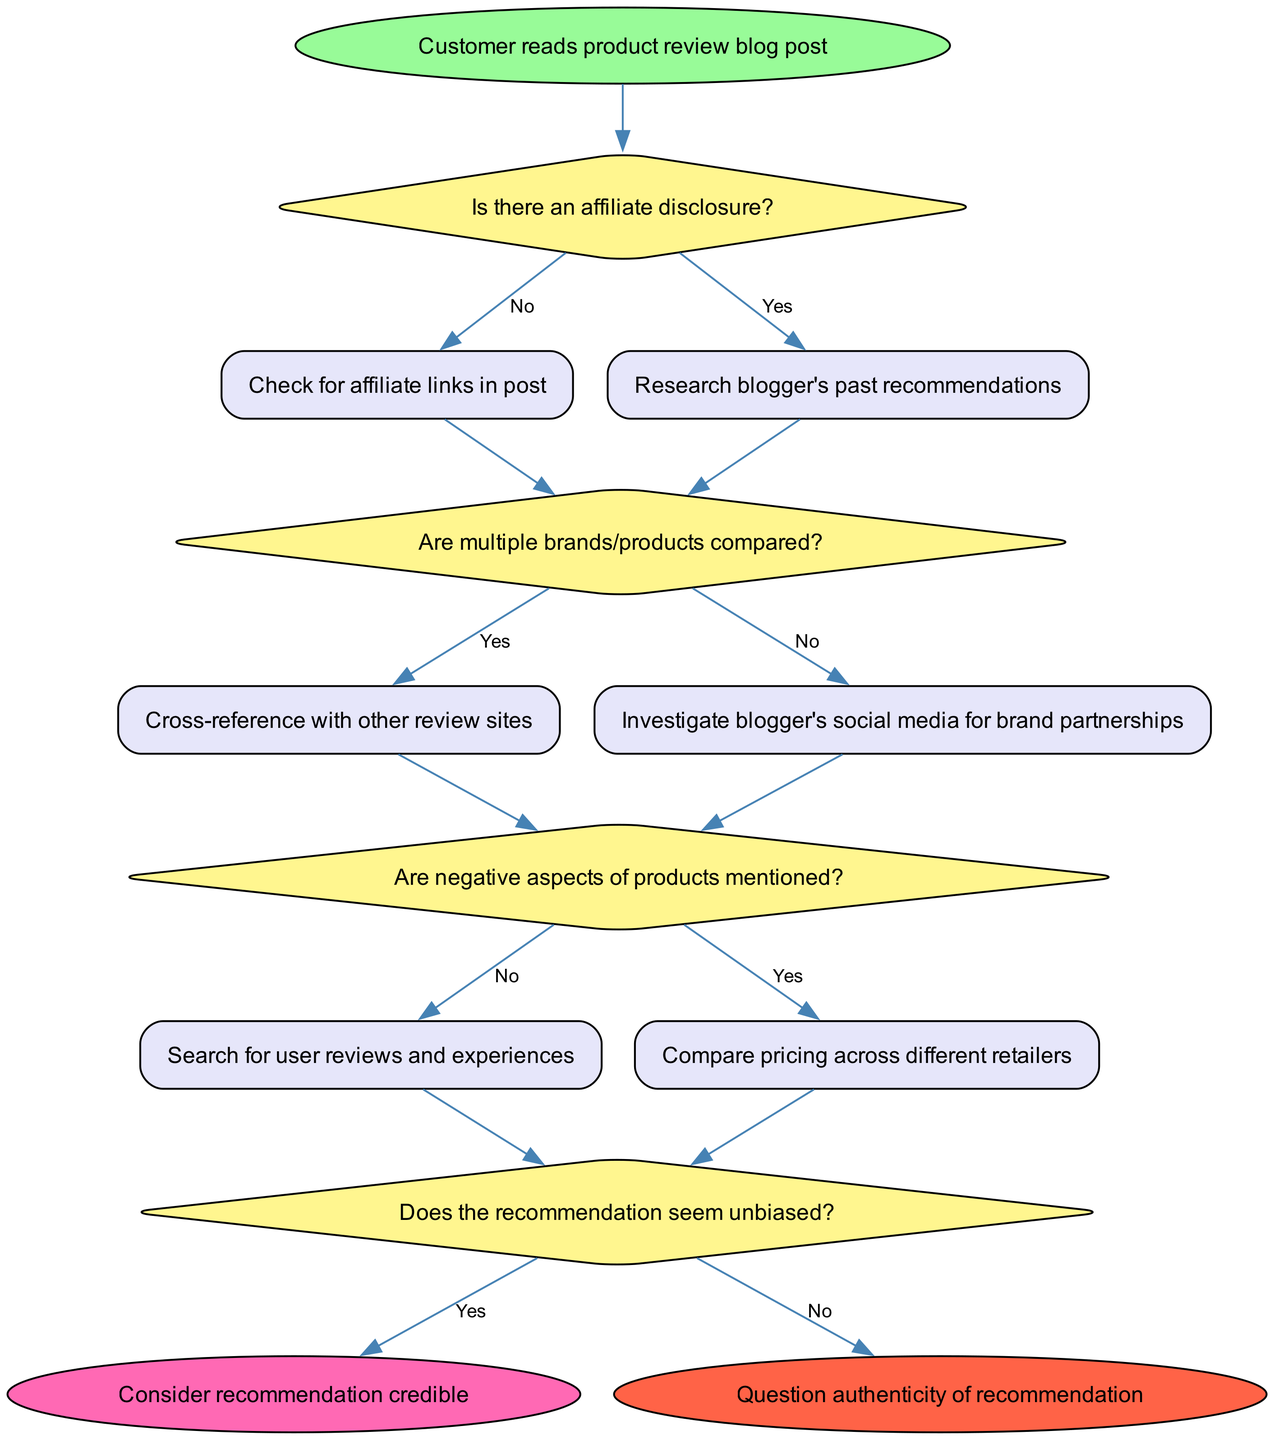Is there an affiliate disclosure? The diagram presents "Is there an affiliate disclosure?" as the first decision node after a customer reads a product review blog post. This node directly asks whether such a disclosure exists, which is fundamental to assessing potential conflicts of interest.
Answer: Yes/No What follows after checking for affiliate links in the post? If there is no affiliate disclosure (the "No" path), the next action taken is to "Check for affiliate links in post." This sequential step ensures that any affiliate relationships can be identified through active links.
Answer: Check for affiliate links in post How many decision nodes are in this diagram? The diagram features four decision nodes: "Is there an affiliate disclosure?", "Are multiple brands/products compared?", "Are negative aspects of products mentioned?", and "Does the recommendation seem unbiased?". The counting of decision nodes indicates complexity in the analysis pathway for potential conflicts of interest.
Answer: Four If there are negative aspects mentioned, what is the next action to take? In the pathway where the decision "Are negative aspects of products mentioned?" is answered with "No", the next action is to "Search for user reviews and experiences". This logically follows the need to gather more data if product criticisms are absent.
Answer: Search for user reviews and experiences What determines whether to consider a recommendation credible? The end point "Consider recommendation credible" is reached if the final decision node "Does the recommendation seem unbiased?" is answered with "Yes". This decision aggregates earlier assessments, indicating it's a summary judgment.
Answer: Yes What happens if the blogger does not disclose affiliations? If the affiliate disclosure check is answered "No", the next action taken is to "Check for affiliate links in post". This step is crucial for addressing potential undisclosed conflicts of interest.
Answer: Check for affiliate links in post Are multiple brands/products compared? This question refers to the second decision node labeled "Are multiple brands/products compared?". The answer here influences subsequent actions, particularly in cross-referencing and assessing the recommendation’s objectivity.
Answer: Yes/No What is the final outcome if the recommendation is deemed unbiased? If the final decision "Does the recommendation seem unbiased?" resolves in the affirmative, the outcome is to "Consider recommendation credible", signifying trust in the product suggestion provided by the blogger.
Answer: Consider recommendation credible 